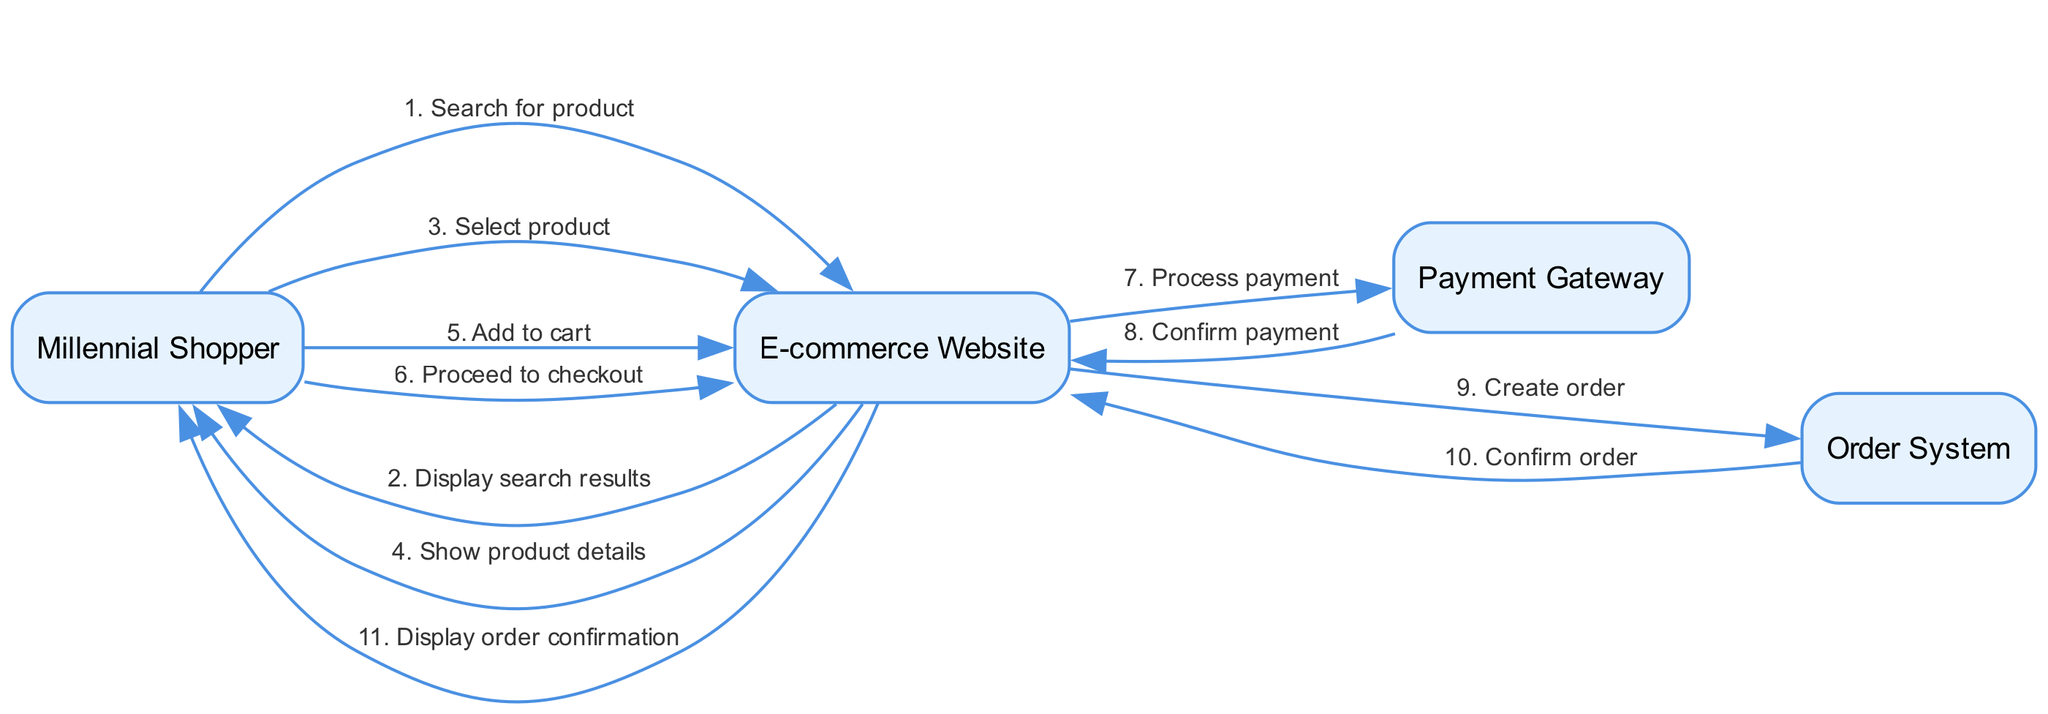What is the first action in the sequence? The first action is initiated by the Millennial Shopper, who searches for a product. This occurs at the very beginning of the sequence, directly after the "Millennial Shopper" node.
Answer: Search for product Which actor confirms the payment? The payment is confirmed by the Payment Gateway. In the sequence, there's a clear message from the Payment Gateway to the E-commerce Website confirming the payment.
Answer: Payment Gateway How many main actors are there in the diagram? The diagram consists of four main actors: Millennial Shopper, E-commerce Website, Payment Gateway, and Order System. These actors are clearly defined in the provided sequence.
Answer: Four What message follows "Add to cart"? After the message "Add to cart" from the Millennial Shopper, the next message is "Proceed to checkout" directed to the E-commerce Website. This shows the flow of actions taken by the shopper.
Answer: Proceed to checkout What is the last action in the sequence? The last action in the sequence is the display of the order confirmation to the Millennial Shopper. This message comes from the E-commerce Website after the order has been confirmed by the Order System.
Answer: Display order confirmation Which actor sends the "Create order" message? The "Create order" message is sent from the E-commerce Website to the Order System. This is part of the process after the payment has been confirmed.
Answer: E-commerce Website How many messages are sent from the Millennial Shopper? The Millennial Shopper sends three messages throughout the sequence: "Search for product," "Select product," and "Add to cart," along with "Proceed to checkout." Counting these, there are four messages in total.
Answer: Four What precedes the "Display order confirmation" action? Before the "Display order confirmation," the last preceding action is "Confirm order," which is sent from the Order System back to the E-commerce Website. This links the final confirmation of the order back to the website's interface.
Answer: Confirm order 